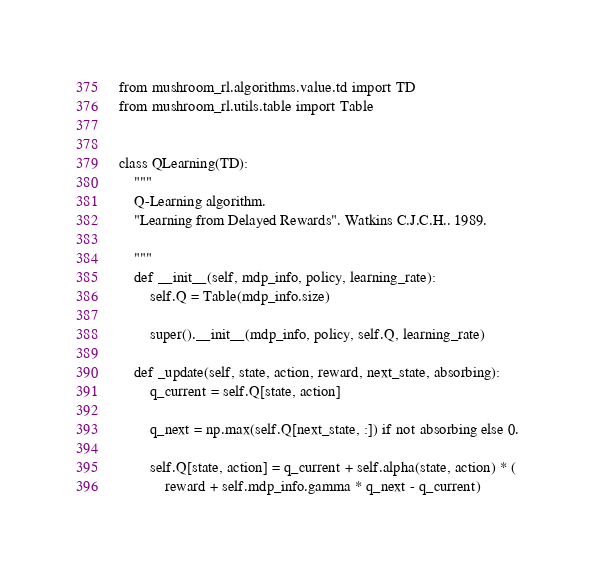<code> <loc_0><loc_0><loc_500><loc_500><_Python_>
from mushroom_rl.algorithms.value.td import TD
from mushroom_rl.utils.table import Table


class QLearning(TD):
    """
    Q-Learning algorithm.
    "Learning from Delayed Rewards". Watkins C.J.C.H.. 1989.

    """
    def __init__(self, mdp_info, policy, learning_rate):
        self.Q = Table(mdp_info.size)

        super().__init__(mdp_info, policy, self.Q, learning_rate)

    def _update(self, state, action, reward, next_state, absorbing):
        q_current = self.Q[state, action]

        q_next = np.max(self.Q[next_state, :]) if not absorbing else 0.

        self.Q[state, action] = q_current + self.alpha(state, action) * (
            reward + self.mdp_info.gamma * q_next - q_current)
</code> 